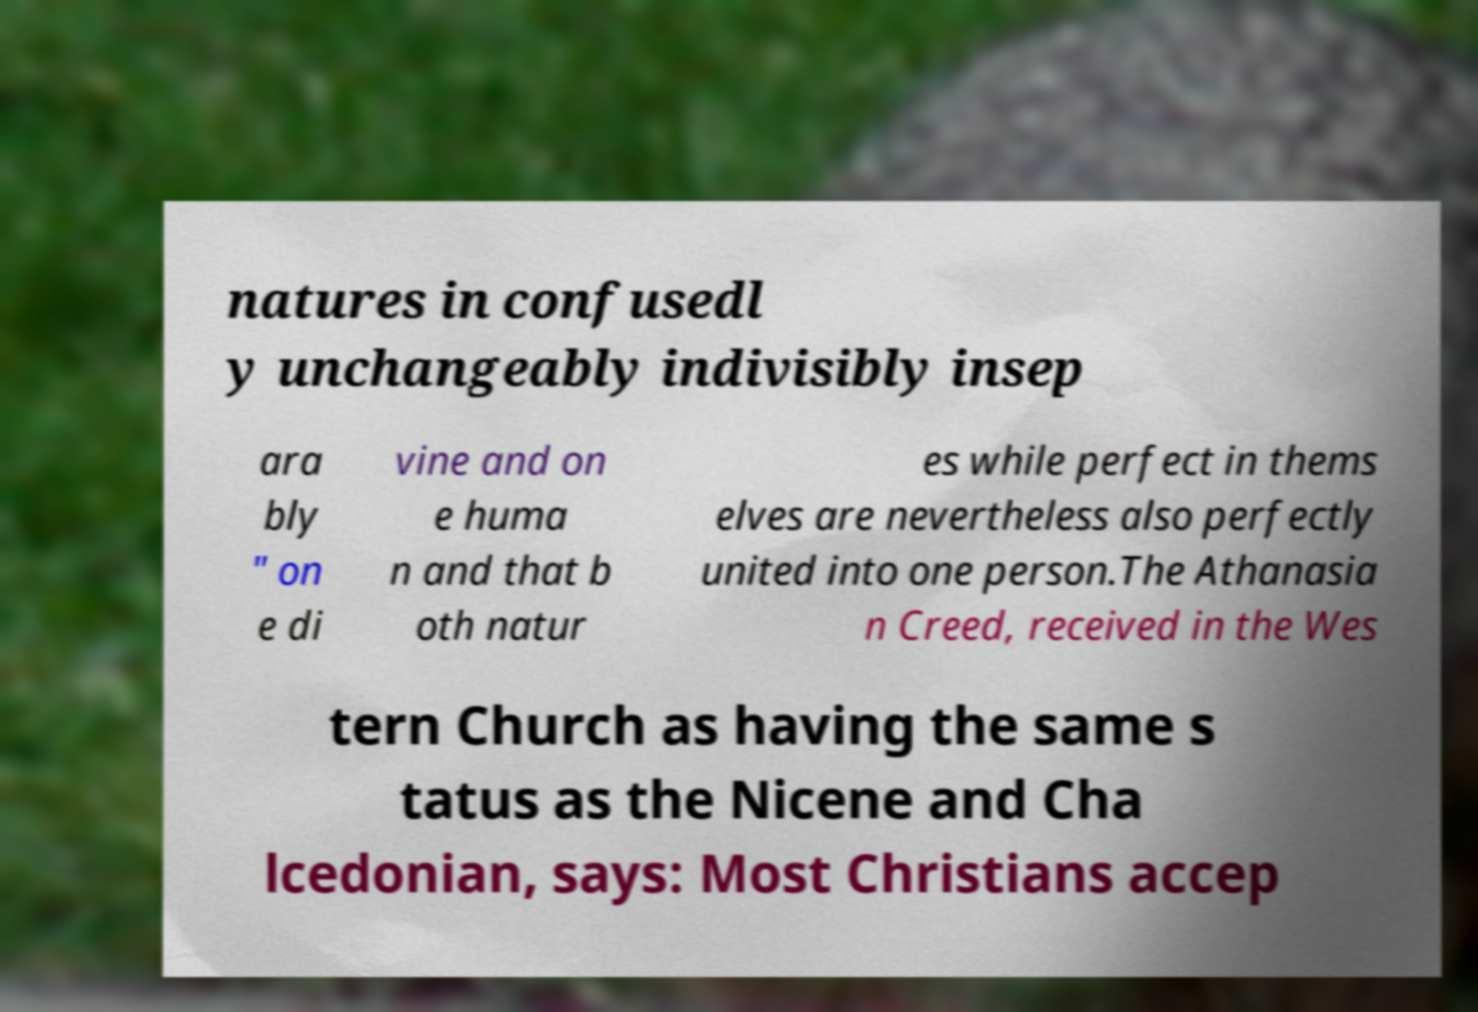There's text embedded in this image that I need extracted. Can you transcribe it verbatim? natures in confusedl y unchangeably indivisibly insep ara bly " on e di vine and on e huma n and that b oth natur es while perfect in thems elves are nevertheless also perfectly united into one person.The Athanasia n Creed, received in the Wes tern Church as having the same s tatus as the Nicene and Cha lcedonian, says: Most Christians accep 